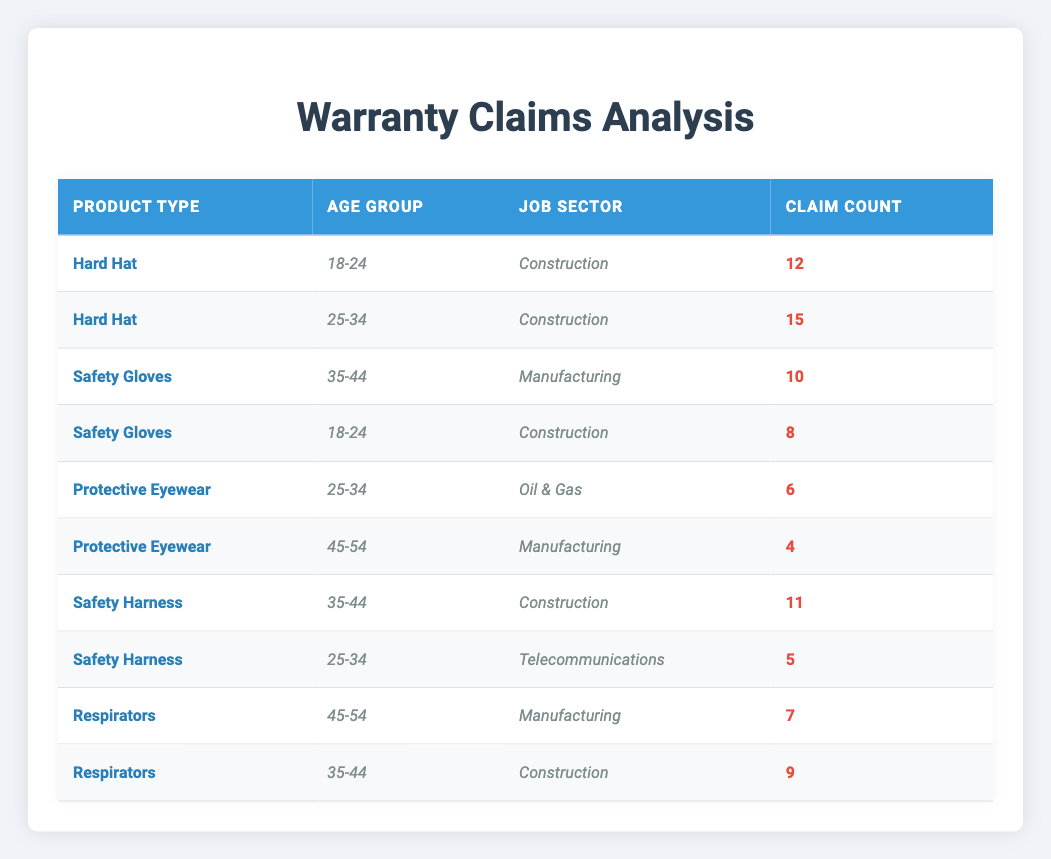What is the total number of warranty claims for Hard Hats? There are two rows for Hard Hats with 12 and 15 claims. Adding them gives 12 + 15 = 27.
Answer: 27 Which age group has the highest number of claims for Safety Gloves? There are two entries for Safety Gloves. The first for age group 35-44 has 10 claims, and the second for age group 18-24 has 8 claims. Therefore, the age group 35-44 has the highest number of claims.
Answer: 35-44 Did customers from the Telecommunications job sector have any warranty claims for Hard Hats? The table does not list any claims for Hard Hats with the Telecommunications job sector. Since there are only claims for Construction and other sectors, the answer is no.
Answer: No What is the difference in claim counts between the highest and lowest claims for Protective Eyewear? There are two rows for Protective Eyewear: one with 6 claims for age group 25-34 and one with 4 claims for age group 45-54. The difference between the highest (6) and lowest (4) claims is 6 - 4 = 2.
Answer: 2 How many total claims were made for products by customers aged 35-44? Customers aged 35-44 appear with claims for Safety Gloves (10), Safety Harness (11), and Respirators (9). Adding these together gives 10 + 11 + 9 = 30 claims.
Answer: 30 Which product type had the fewest claims from the age group 45-54? The only two products with claims for the age group 45-54 are Protective Eyewear with 4 claims and Respirators with 7 claims. Protective Eyewear had the fewest claims.
Answer: Protective Eyewear Is it true that the total number of claims for Safety Harness is greater than the total number for Respirators? For Safety Harness, there were 11 claims (35-44 age group) and 5 claims (25-34 age group) totaling 11 + 5 = 16 claims. For Respirators, there were 7 claims (45-54) and 9 claims (35-44) totaling 7 + 9 = 16 claims. Since both total 16, it is false that Safety Harness has greater claims.
Answer: No What product had the highest number of claims from the age group 25-34? The only products with claims for age group 25-34 are: Hard Hats with 15 claims and Protective Eyewear with 6 claims. Hard Hats has the highest claims with 15.
Answer: Hard Hat Which job sector has the least warranty claims among the products listed? Looking at the job sectors: Construction has 12 + 15 + 11 + 9 = 47 claims; Manufacturing has 10 + 4 + 7 = 21 claims; Oil & Gas has 6 claims, and Telecommunications has 5 claims. The job sector with the least claims is Telecommunications with 5.
Answer: Telecommunications 